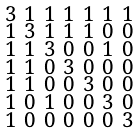Convert formula to latex. <formula><loc_0><loc_0><loc_500><loc_500>\begin{smallmatrix} 3 & 1 & 1 & 1 & 1 & 1 & 1 \\ 1 & 3 & 1 & 1 & 1 & 0 & 0 \\ 1 & 1 & 3 & 0 & 0 & 1 & 0 \\ 1 & 1 & 0 & 3 & 0 & 0 & 0 \\ 1 & 1 & 0 & 0 & 3 & 0 & 0 \\ 1 & 0 & 1 & 0 & 0 & 3 & 0 \\ 1 & 0 & 0 & 0 & 0 & 0 & 3 \end{smallmatrix}</formula> 